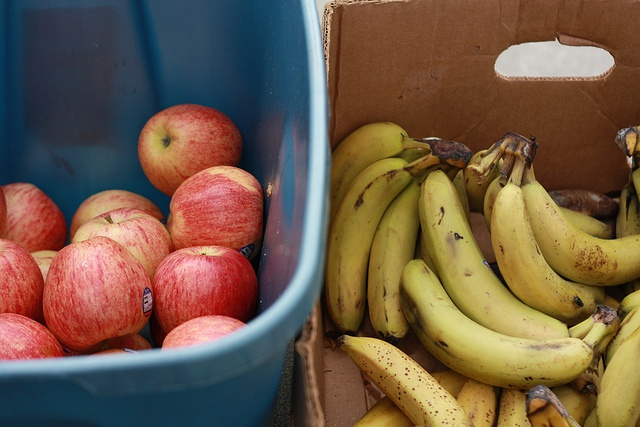Describe the objects in this image and their specific colors. I can see apple in darkblue, salmon, and brown tones, banana in darkblue, olive, and maroon tones, banana in darkblue, tan, and olive tones, banana in darkblue, khaki, and tan tones, and banana in darkblue, tan, olive, and khaki tones in this image. 